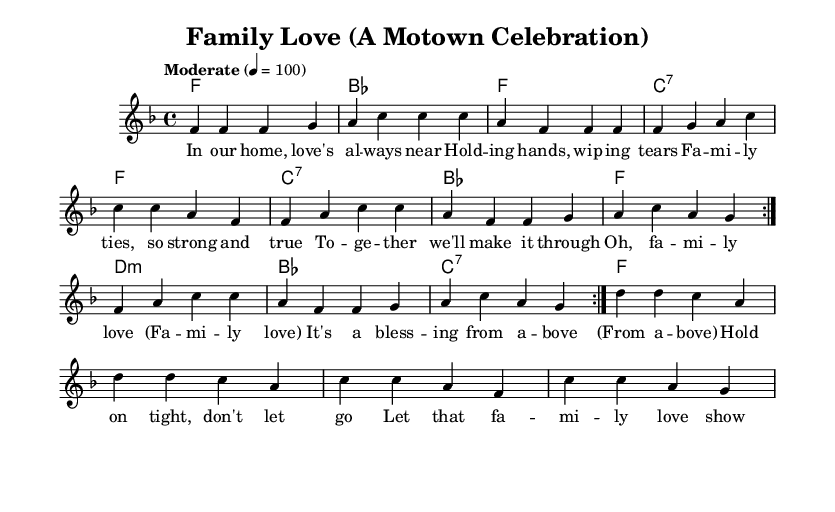What is the key signature of this music? The key signature is F major, which has one flat (B flat).
Answer: F major What is the time signature of the piece? The time signature is 4/4, indicating four beats per measure.
Answer: 4/4 What is the tempo marking for this piece? The tempo marking is "Moderate" at a quarter note equals 100 beats per minute.
Answer: Moderate How many times is the verse repeated? The verse is repeated two times as indicated by the \repeat volta 2 notation.
Answer: 2 What is the first lyric of the chorus? The first lyric of the chorus is "Oh, family love." This can be found at the starting line of the chorus section in the lyrics.
Answer: Oh, family love What chord is played with the lyrics "Holding hands, wiping tears"? The chord played with those lyrics is F major, as seen in the harmonies section aligned with the corresponding lyrics.
Answer: F What musical genre does this piece represent? The musical genre is Rhythm and blues, as described in the title and theme regarding classic Motown hits.
Answer: Rhythm and blues 